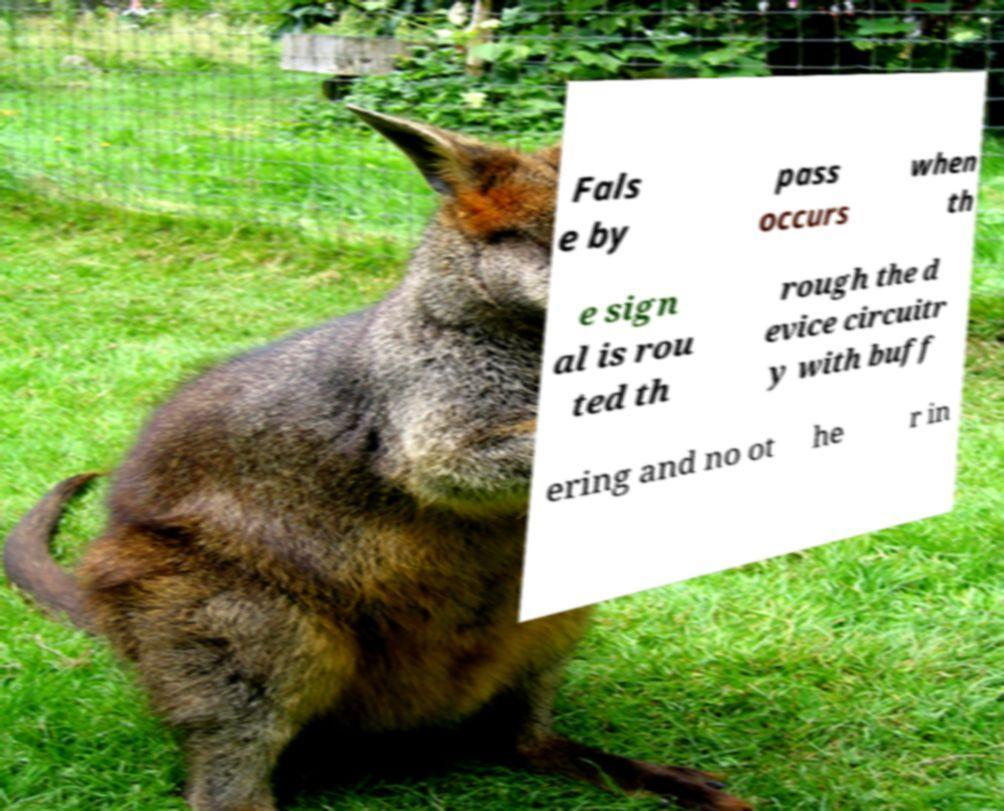What messages or text are displayed in this image? I need them in a readable, typed format. Fals e by pass occurs when th e sign al is rou ted th rough the d evice circuitr y with buff ering and no ot he r in 